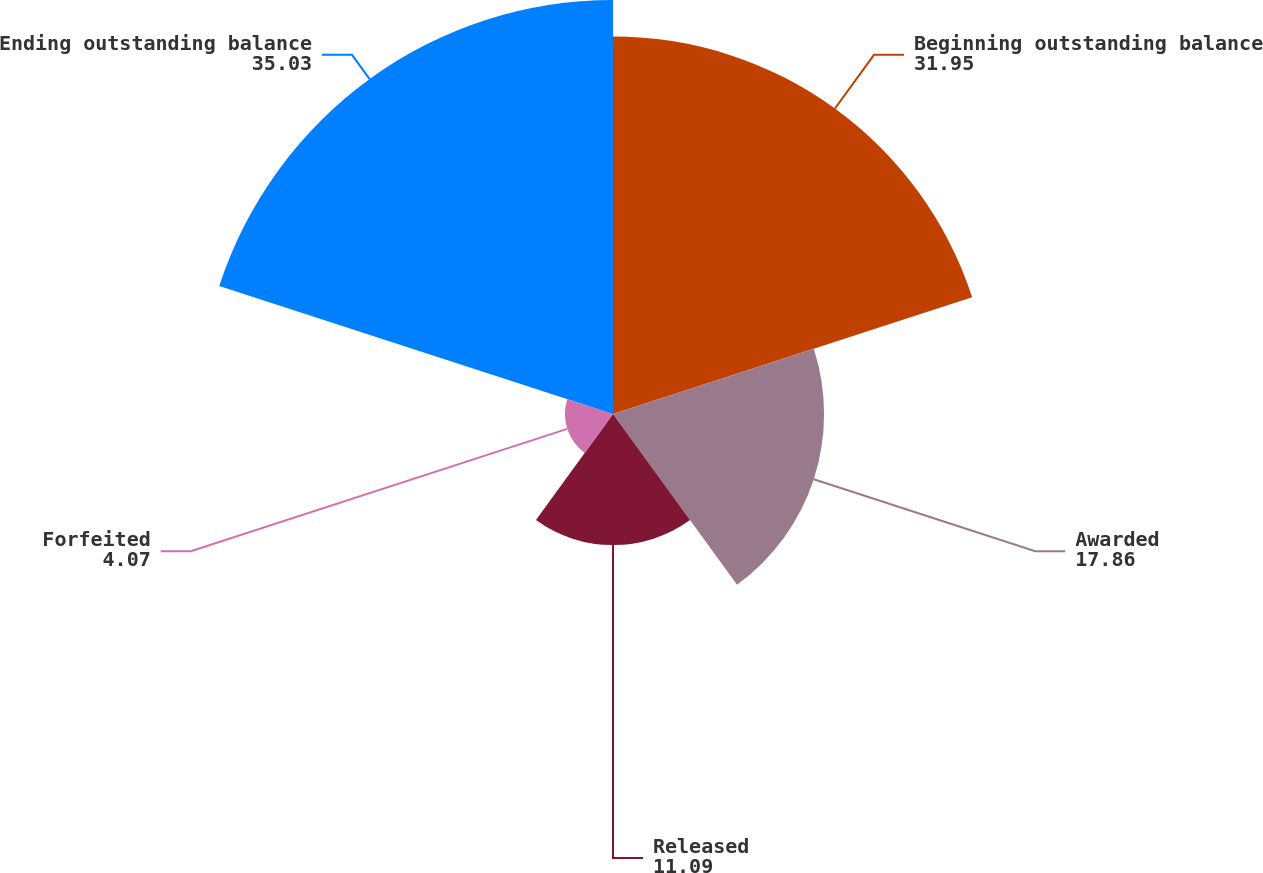<chart> <loc_0><loc_0><loc_500><loc_500><pie_chart><fcel>Beginning outstanding balance<fcel>Awarded<fcel>Released<fcel>Forfeited<fcel>Ending outstanding balance<nl><fcel>31.95%<fcel>17.86%<fcel>11.09%<fcel>4.07%<fcel>35.03%<nl></chart> 